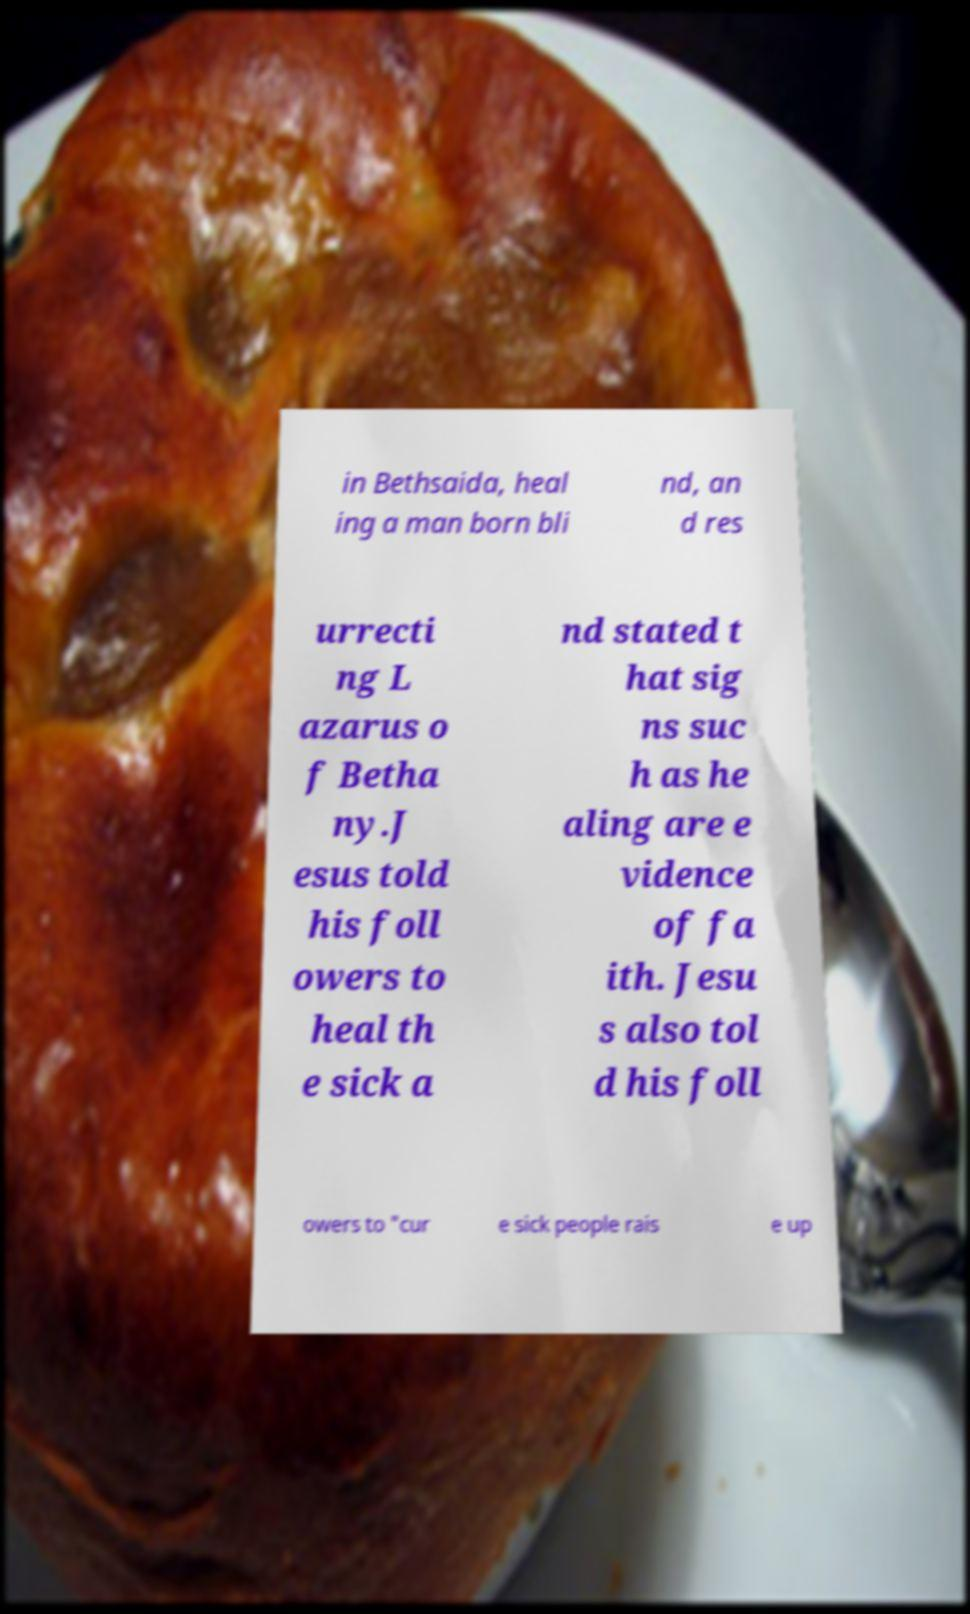Could you extract and type out the text from this image? in Bethsaida, heal ing a man born bli nd, an d res urrecti ng L azarus o f Betha ny.J esus told his foll owers to heal th e sick a nd stated t hat sig ns suc h as he aling are e vidence of fa ith. Jesu s also tol d his foll owers to "cur e sick people rais e up 